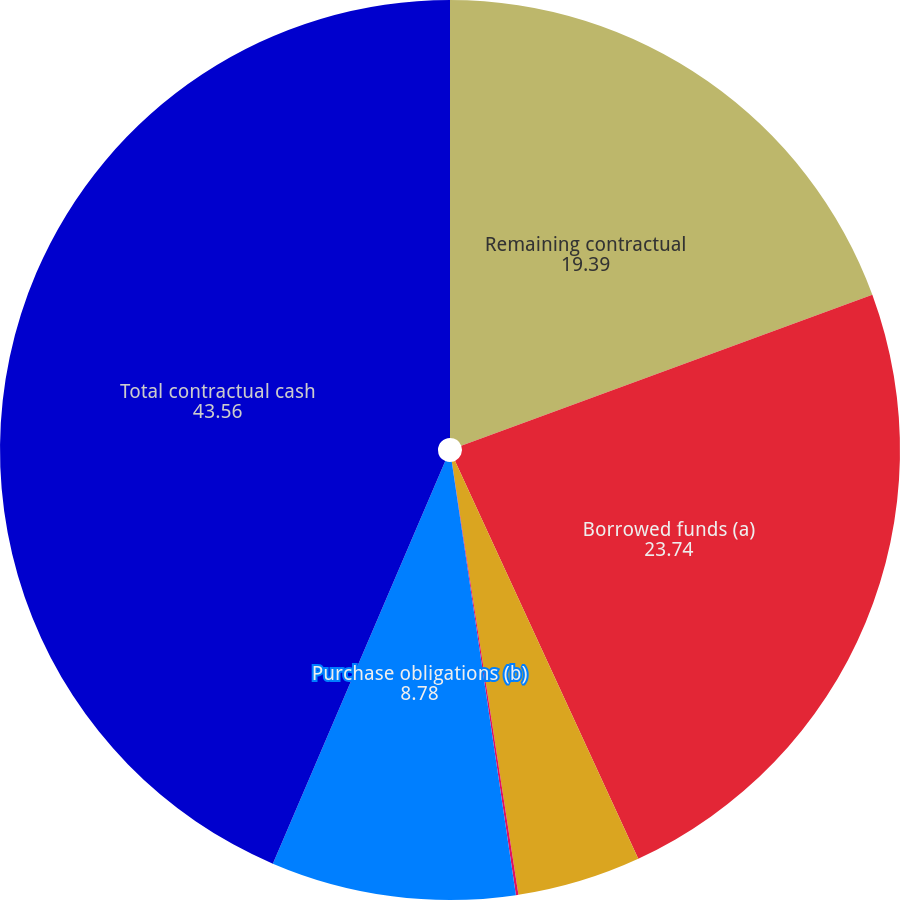Convert chart. <chart><loc_0><loc_0><loc_500><loc_500><pie_chart><fcel>Remaining contractual<fcel>Borrowed funds (a)<fcel>Minimum annual rentals on<fcel>Nonqualified pension and<fcel>Purchase obligations (b)<fcel>Total contractual cash<nl><fcel>19.39%<fcel>23.74%<fcel>4.44%<fcel>0.09%<fcel>8.78%<fcel>43.56%<nl></chart> 